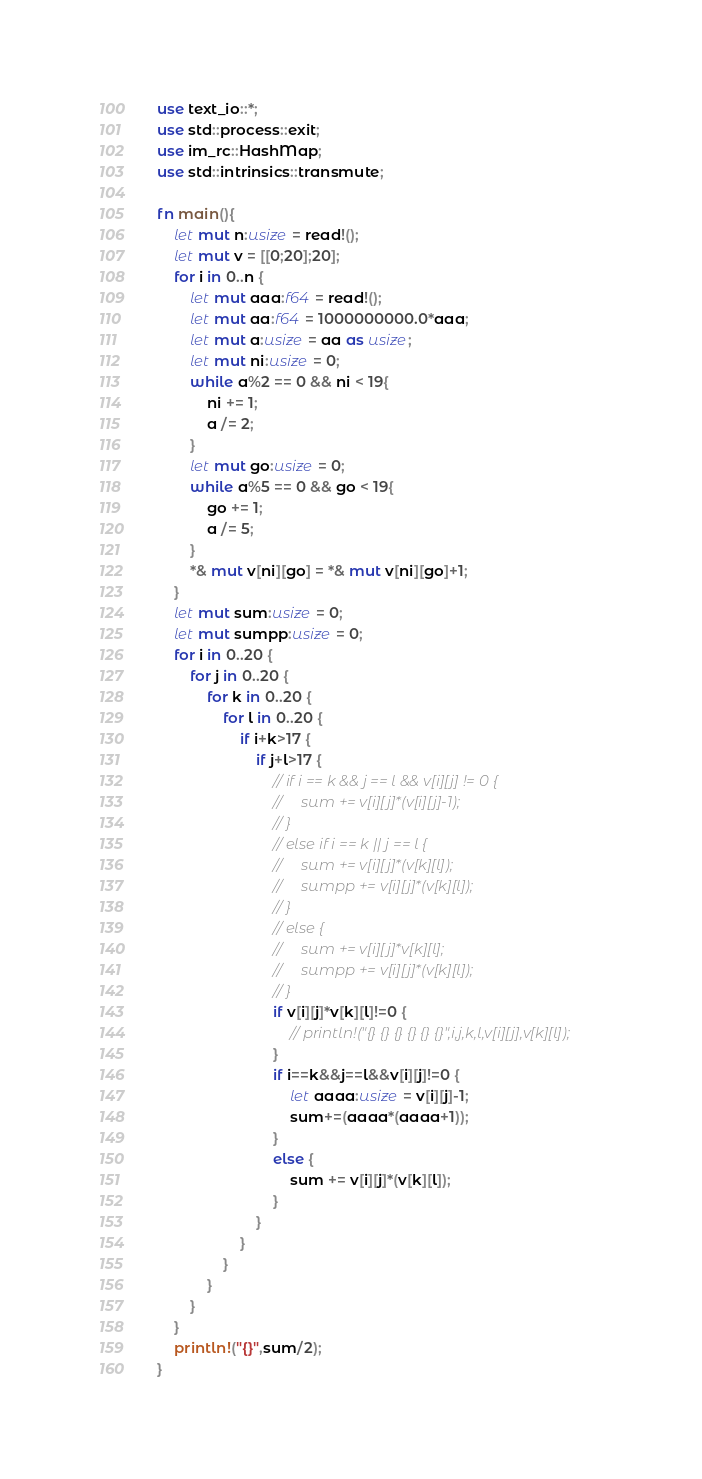<code> <loc_0><loc_0><loc_500><loc_500><_Rust_>use text_io::*;
use std::process::exit;
use im_rc::HashMap;
use std::intrinsics::transmute;

fn main(){
    let mut n:usize = read!();
    let mut v = [[0;20];20];
    for i in 0..n {
        let mut aaa:f64 = read!();
        let mut aa:f64 = 1000000000.0*aaa;
        let mut a:usize = aa as usize;
        let mut ni:usize = 0;
        while a%2 == 0 && ni < 19{
            ni += 1;
            a /= 2;
        }
        let mut go:usize = 0;
        while a%5 == 0 && go < 19{
            go += 1;
            a /= 5;
        }
        *& mut v[ni][go] = *& mut v[ni][go]+1;
    }
    let mut sum:usize = 0;
    let mut sumpp:usize = 0;
    for i in 0..20 {
        for j in 0..20 {
            for k in 0..20 {
                for l in 0..20 {
                    if i+k>17 {
                        if j+l>17 {
                            // if i == k && j == l && v[i][j] != 0 {
                            //     sum += v[i][j]*(v[i][j]-1);
                            // }
                            // else if i == k || j == l {
                            //     sum += v[i][j]*(v[k][l]);
                            //     sumpp += v[i][j]*(v[k][l]);
                            // }
                            // else {
                            //     sum += v[i][j]*v[k][l];
                            //     sumpp += v[i][j]*(v[k][l]);
                            // }
                            if v[i][j]*v[k][l]!=0 {
                                // println!("{} {} {} {} {} {}",i,j,k,l,v[i][j],v[k][l]);
                            }
                            if i==k&&j==l&&v[i][j]!=0 {
                                let aaaa:usize = v[i][j]-1;
                                sum+=(aaaa*(aaaa+1));
                            }
                            else {
                                sum += v[i][j]*(v[k][l]);
                            }
                        }
                    }
                }
            }
        }
    }
    println!("{}",sum/2);
}</code> 